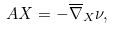Convert formula to latex. <formula><loc_0><loc_0><loc_500><loc_500>A X = - \overline { \nabla } _ { X } \nu ,</formula> 